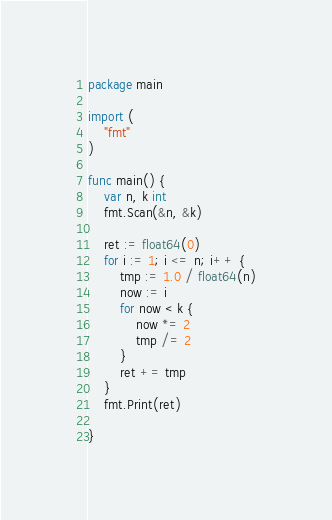<code> <loc_0><loc_0><loc_500><loc_500><_Go_>package main

import (
	"fmt"
)

func main() {
	var n, k int
	fmt.Scan(&n, &k)

	ret := float64(0)
	for i := 1; i <= n; i++ {
		tmp := 1.0 / float64(n)
		now := i
		for now < k {
			now *= 2
			tmp /= 2
		}
		ret += tmp
	}
	fmt.Print(ret)

}
</code> 